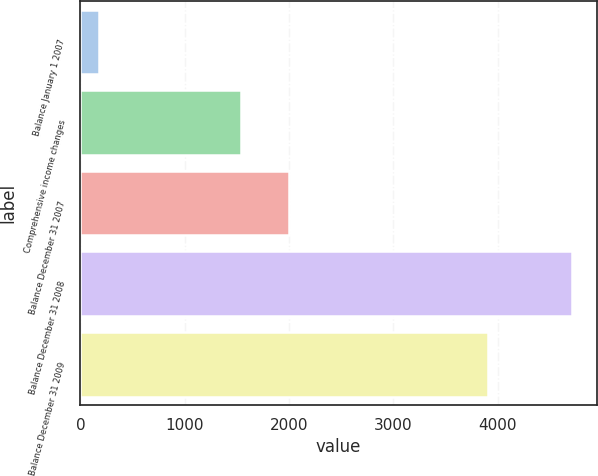Convert chart. <chart><loc_0><loc_0><loc_500><loc_500><bar_chart><fcel>Balance January 1 2007<fcel>Comprehensive income changes<fcel>Balance December 31 2007<fcel>Balance December 31 2008<fcel>Balance December 31 2009<nl><fcel>175<fcel>1541.9<fcel>1995.8<fcel>4714<fcel>3904.9<nl></chart> 